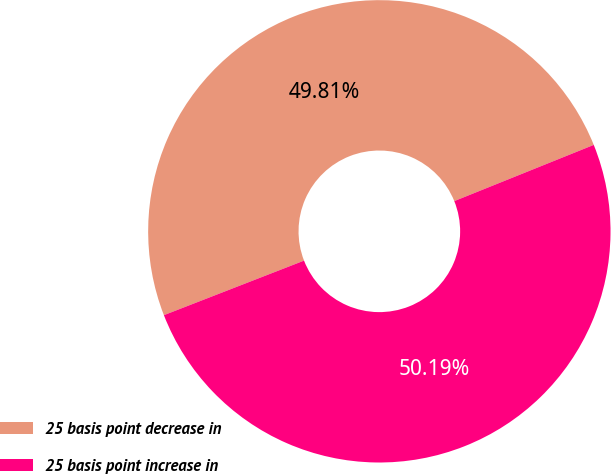Convert chart to OTSL. <chart><loc_0><loc_0><loc_500><loc_500><pie_chart><fcel>25 basis point decrease in<fcel>25 basis point increase in<nl><fcel>49.81%<fcel>50.19%<nl></chart> 